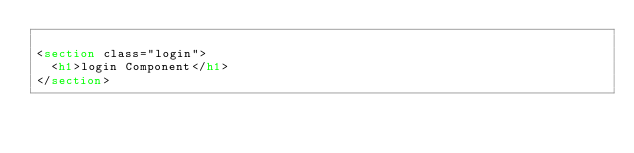Convert code to text. <code><loc_0><loc_0><loc_500><loc_500><_HTML_>
<section class="login">
  <h1>login Component</h1>
</section>

</code> 